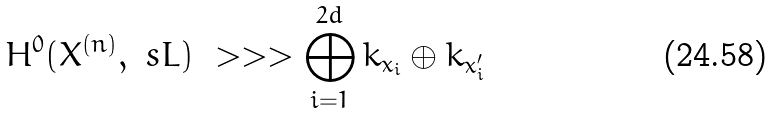<formula> <loc_0><loc_0><loc_500><loc_500>H ^ { 0 } ( X ^ { ( n ) } , \ s L ) \ > > > \bigoplus _ { i = 1 } ^ { 2 d } k _ { x _ { i } } \oplus k _ { x ^ { \prime } _ { i } }</formula> 